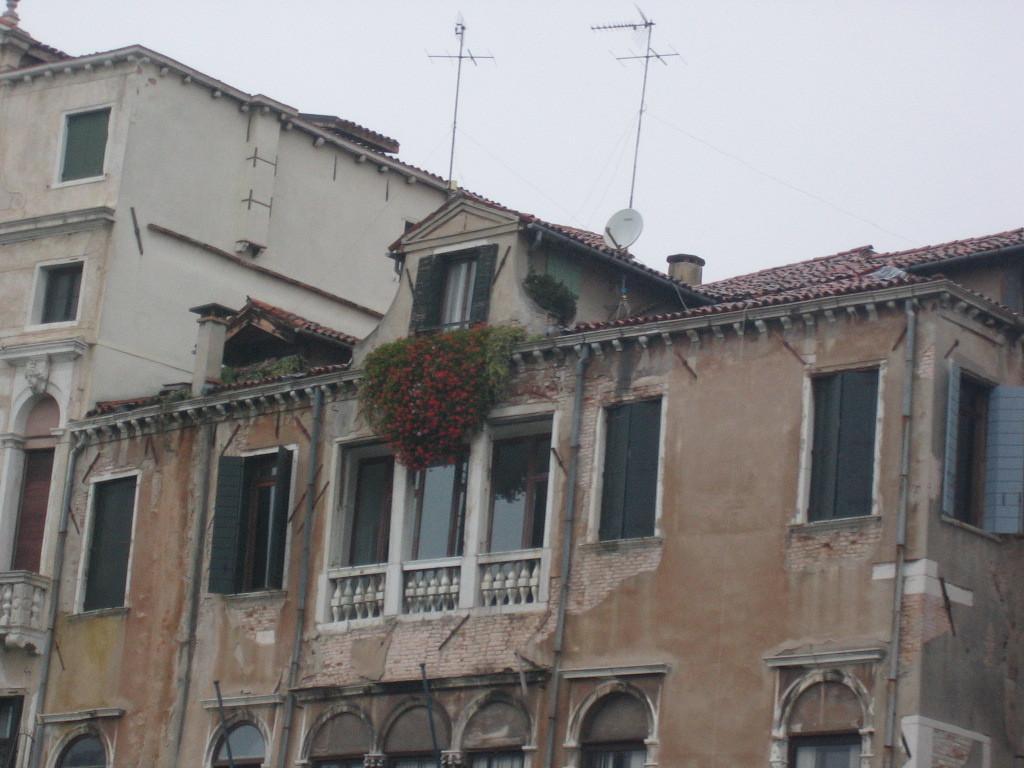How would you summarize this image in a sentence or two? As we can see in the image there are buildings, plants, flowers, rooftop, window and on the top there is sky. 